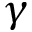Convert formula to latex. <formula><loc_0><loc_0><loc_500><loc_500>\gamma</formula> 